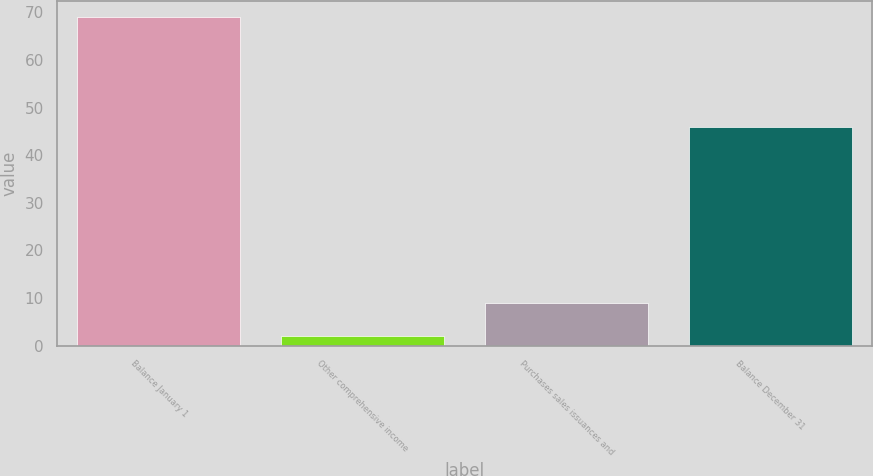Convert chart to OTSL. <chart><loc_0><loc_0><loc_500><loc_500><bar_chart><fcel>Balance January 1<fcel>Other comprehensive income<fcel>Purchases sales issuances and<fcel>Balance December 31<nl><fcel>69<fcel>2<fcel>9<fcel>46<nl></chart> 